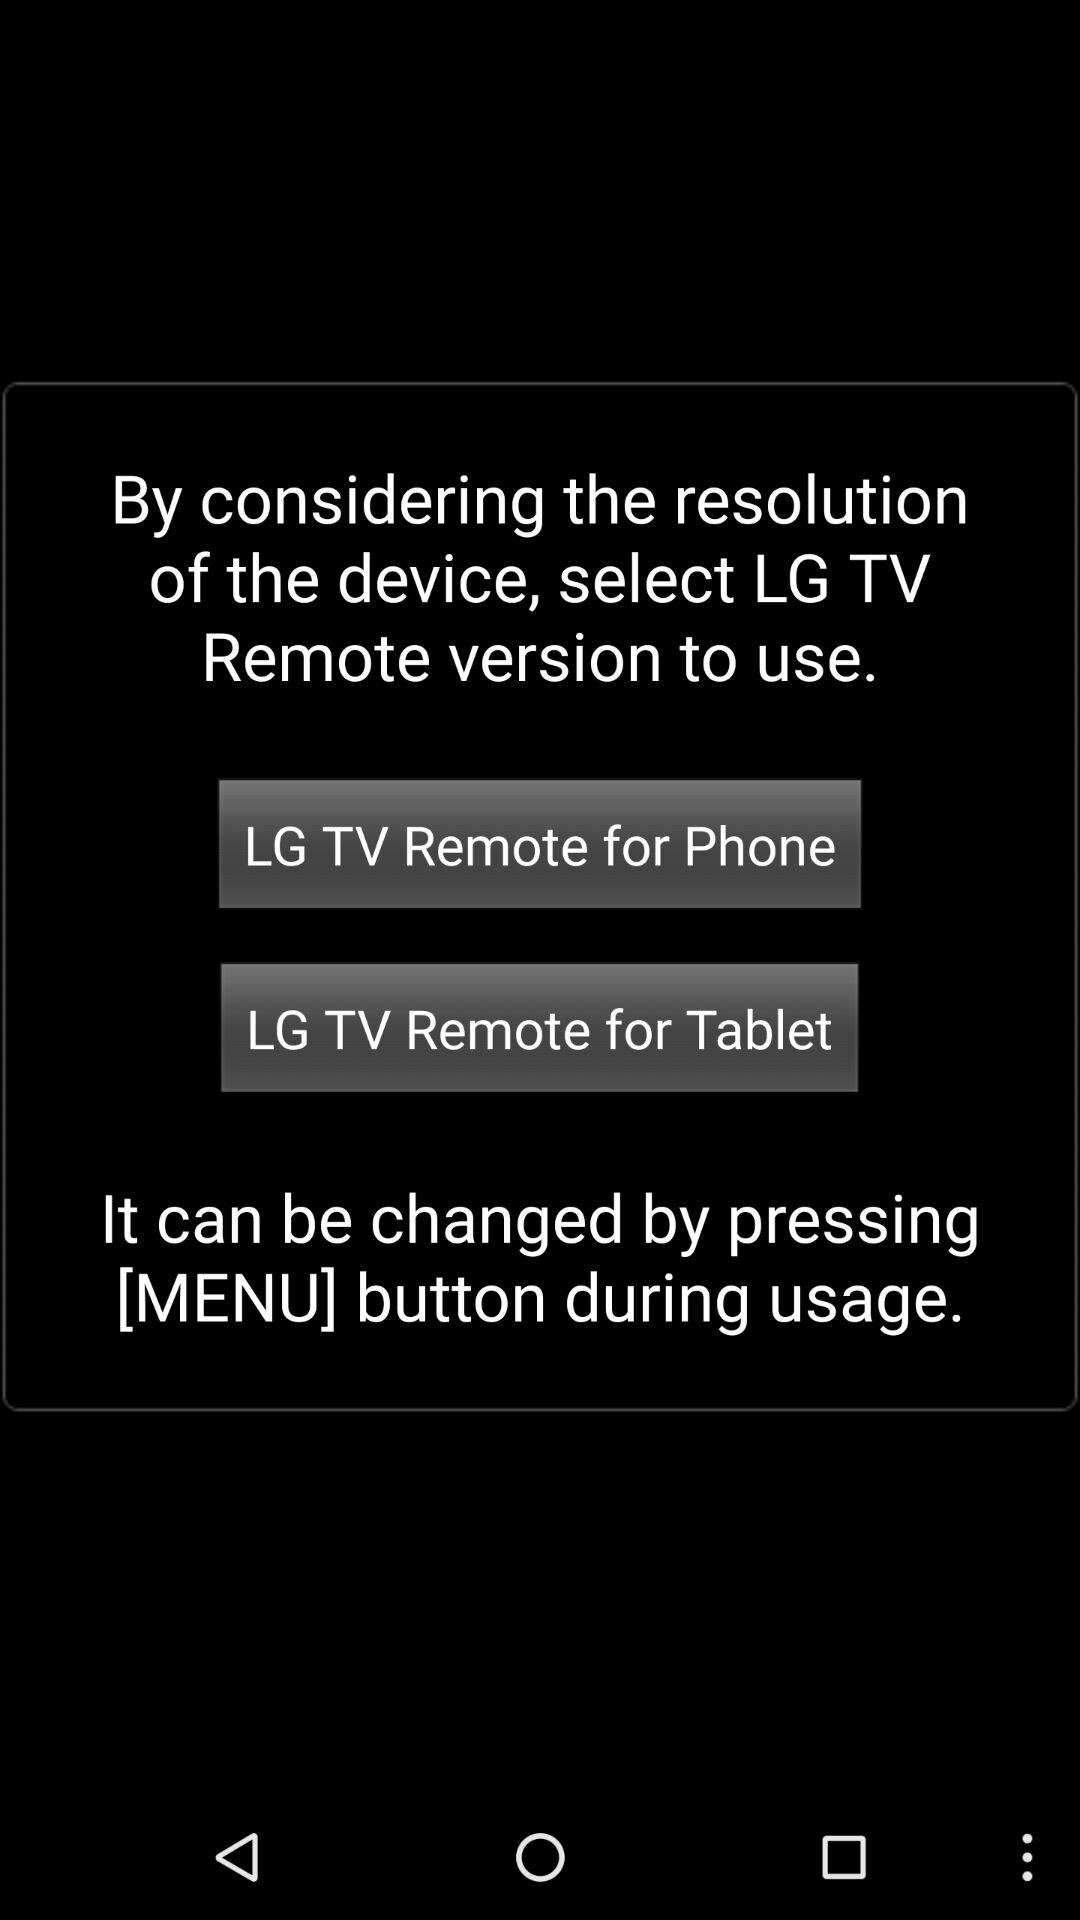How many LG TV Remote versions are there?
Answer the question using a single word or phrase. 2 